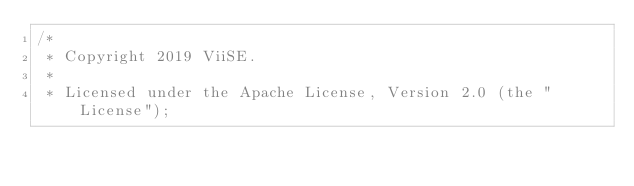Convert code to text. <code><loc_0><loc_0><loc_500><loc_500><_Java_>/*
 * Copyright 2019 ViiSE.
 *
 * Licensed under the Apache License, Version 2.0 (the "License");</code> 